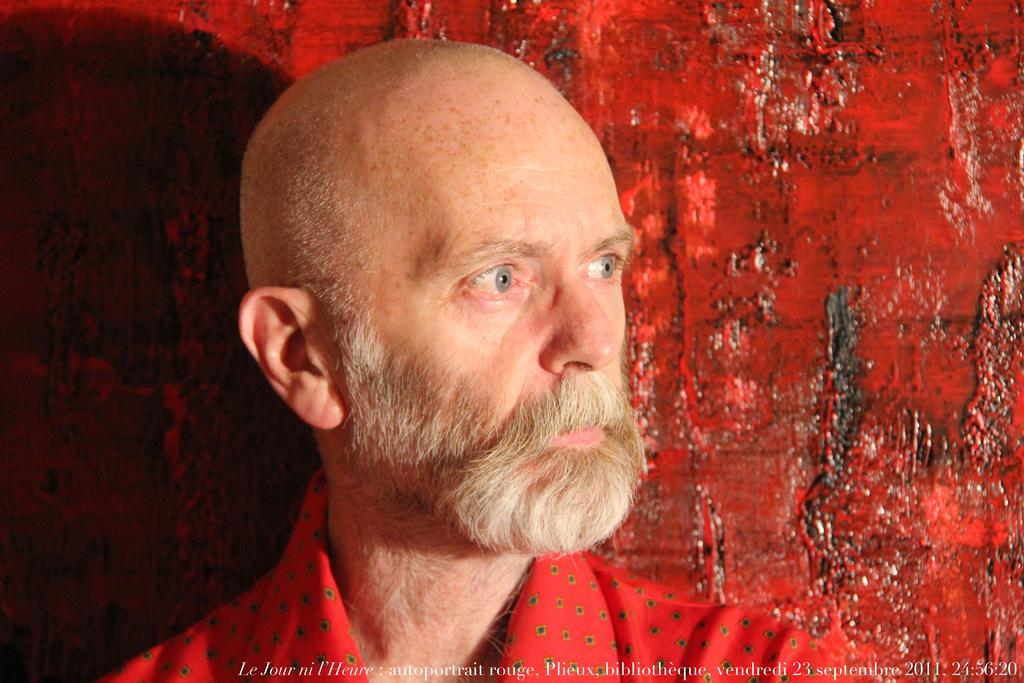What is the appearance of the man in the image? There is a man with a beard in the image. What color is the background in the image? There is a red background in the image. Is there any text or label in the image? Yes, there is a name at the bottom of the image. How many fowl are perched on the man's elbow in the image? There are no fowl present in the image, and the man's elbow is not visible. What type of goat can be seen interacting with the man in the image? There is no goat present in the image; it only features a man with a beard. 